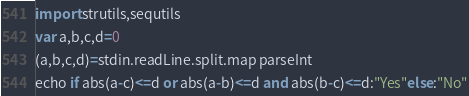<code> <loc_0><loc_0><loc_500><loc_500><_Nim_>import strutils,sequtils
var a,b,c,d=0
(a,b,c,d)=stdin.readLine.split.map parseInt
echo if abs(a-c)<=d or abs(a-b)<=d and abs(b-c)<=d:"Yes"else:"No"</code> 